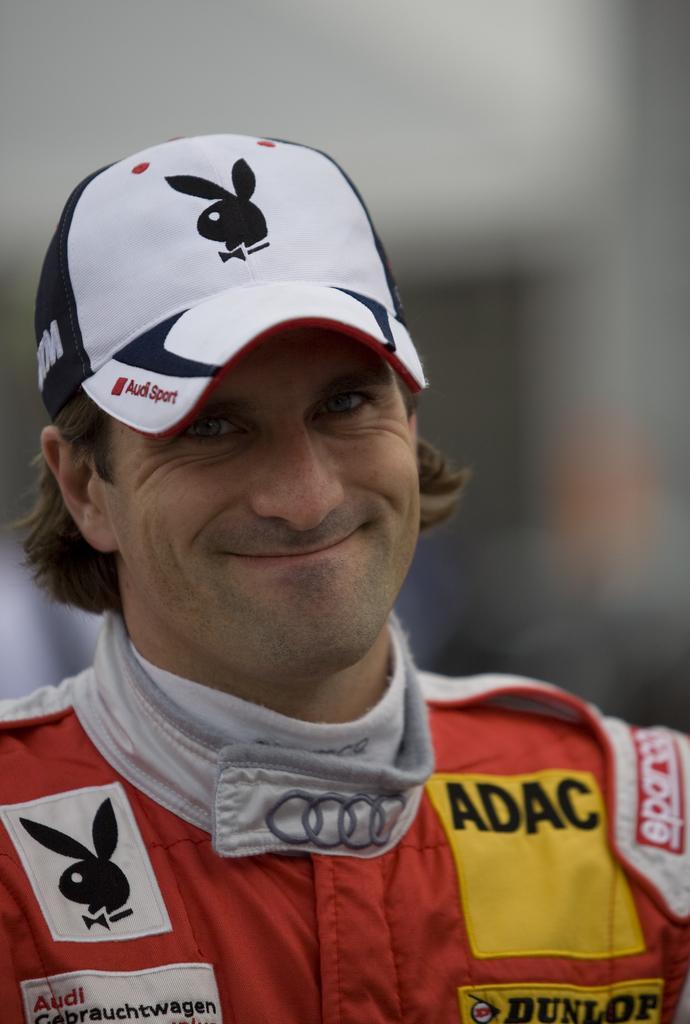In one or two sentences, can you explain what this image depicts? There is a person in orange color shirt, wearing a cap and smiling. And the background is blurred. 